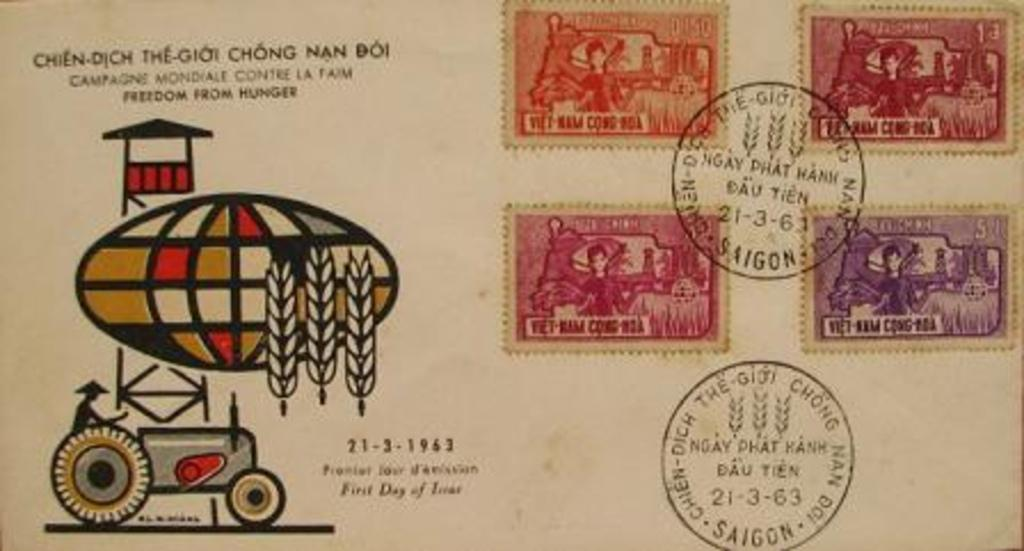What is the main subject of the image? The main subject of the image is a picture. What is depicted in the picture? The picture contains a group of stamps. Is there any text present in the image? Yes, there is text on the picture. What type of thread is being used by the fairies in the image? There are no fairies present in the image, and therefore no thread being used by them. 